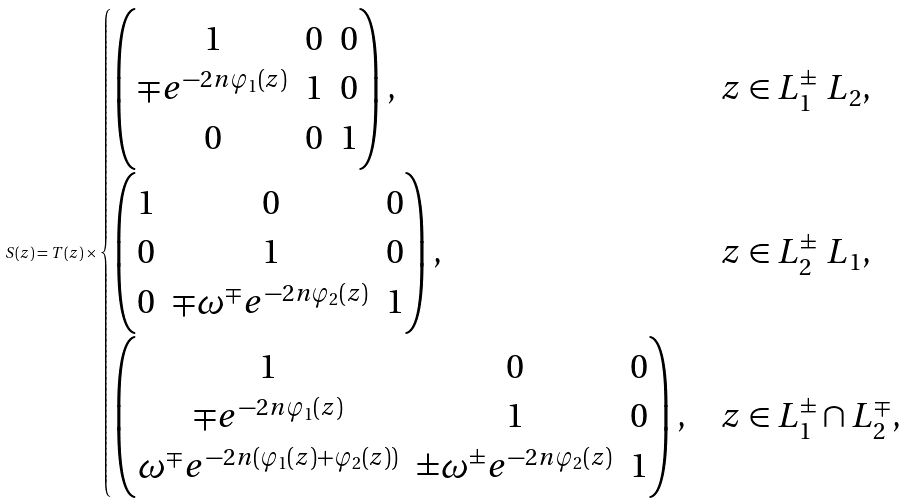Convert formula to latex. <formula><loc_0><loc_0><loc_500><loc_500>S ( z ) = T ( z ) \times \begin{cases} \begin{pmatrix} 1 & 0 & 0 \\ \mp e ^ { - 2 n \varphi _ { 1 } ( z ) } & 1 & 0 \\ 0 & 0 & 1 \end{pmatrix} , & z \in L _ { 1 } ^ { \pm } \ L _ { 2 } , \\ \begin{pmatrix} 1 & 0 & 0 \\ 0 & 1 & 0 \\ 0 & \mp \omega ^ { \mp } e ^ { - 2 n \varphi _ { 2 } ( z ) } & 1 \end{pmatrix} , & z \in L _ { 2 } ^ { \pm } \ L _ { 1 } , \\ \begin{pmatrix} 1 & 0 & 0 \\ \mp e ^ { - 2 n \varphi _ { 1 } ( z ) } & 1 & 0 \\ \omega ^ { \mp } e ^ { - 2 n ( \varphi _ { 1 } ( z ) + \varphi _ { 2 } ( z ) ) } & \pm \omega ^ { \pm } e ^ { - 2 n \varphi _ { 2 } ( z ) } & 1 \end{pmatrix} , & z \in L _ { 1 } ^ { \pm } \cap L _ { 2 } ^ { \mp } , \end{cases}</formula> 